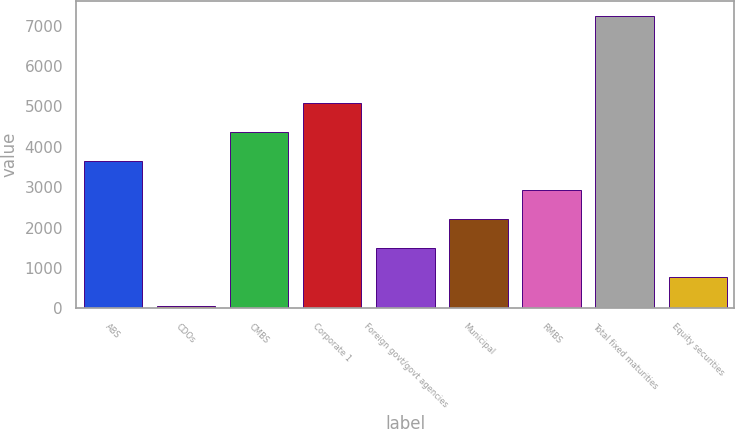Convert chart to OTSL. <chart><loc_0><loc_0><loc_500><loc_500><bar_chart><fcel>ABS<fcel>CDOs<fcel>CMBS<fcel>Corporate 1<fcel>Foreign govt/govt agencies<fcel>Municipal<fcel>RMBS<fcel>Total fixed maturities<fcel>Equity securities<nl><fcel>3651<fcel>59<fcel>4369.4<fcel>5087.8<fcel>1495.8<fcel>2214.2<fcel>2932.6<fcel>7243<fcel>777.4<nl></chart> 